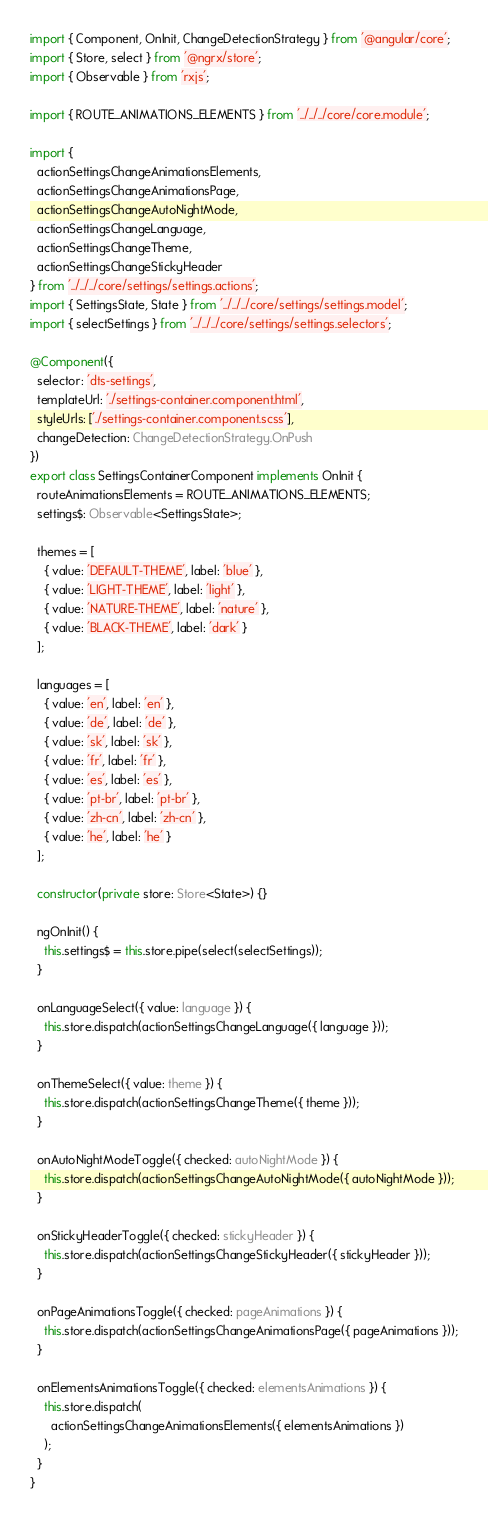Convert code to text. <code><loc_0><loc_0><loc_500><loc_500><_TypeScript_>import { Component, OnInit, ChangeDetectionStrategy } from '@angular/core';
import { Store, select } from '@ngrx/store';
import { Observable } from 'rxjs';

import { ROUTE_ANIMATIONS_ELEMENTS } from '../../../core/core.module';

import {
  actionSettingsChangeAnimationsElements,
  actionSettingsChangeAnimationsPage,
  actionSettingsChangeAutoNightMode,
  actionSettingsChangeLanguage,
  actionSettingsChangeTheme,
  actionSettingsChangeStickyHeader
} from '../../../core/settings/settings.actions';
import { SettingsState, State } from '../../../core/settings/settings.model';
import { selectSettings } from '../../../core/settings/settings.selectors';

@Component({
  selector: 'dts-settings',
  templateUrl: './settings-container.component.html',
  styleUrls: ['./settings-container.component.scss'],
  changeDetection: ChangeDetectionStrategy.OnPush
})
export class SettingsContainerComponent implements OnInit {
  routeAnimationsElements = ROUTE_ANIMATIONS_ELEMENTS;
  settings$: Observable<SettingsState>;

  themes = [
    { value: 'DEFAULT-THEME', label: 'blue' },
    { value: 'LIGHT-THEME', label: 'light' },
    { value: 'NATURE-THEME', label: 'nature' },
    { value: 'BLACK-THEME', label: 'dark' }
  ];

  languages = [
    { value: 'en', label: 'en' },
    { value: 'de', label: 'de' },
    { value: 'sk', label: 'sk' },
    { value: 'fr', label: 'fr' },
    { value: 'es', label: 'es' },
    { value: 'pt-br', label: 'pt-br' },
    { value: 'zh-cn', label: 'zh-cn' },
    { value: 'he', label: 'he' }
  ];

  constructor(private store: Store<State>) {}

  ngOnInit() {
    this.settings$ = this.store.pipe(select(selectSettings));
  }

  onLanguageSelect({ value: language }) {
    this.store.dispatch(actionSettingsChangeLanguage({ language }));
  }

  onThemeSelect({ value: theme }) {
    this.store.dispatch(actionSettingsChangeTheme({ theme }));
  }

  onAutoNightModeToggle({ checked: autoNightMode }) {
    this.store.dispatch(actionSettingsChangeAutoNightMode({ autoNightMode }));
  }

  onStickyHeaderToggle({ checked: stickyHeader }) {
    this.store.dispatch(actionSettingsChangeStickyHeader({ stickyHeader }));
  }

  onPageAnimationsToggle({ checked: pageAnimations }) {
    this.store.dispatch(actionSettingsChangeAnimationsPage({ pageAnimations }));
  }

  onElementsAnimationsToggle({ checked: elementsAnimations }) {
    this.store.dispatch(
      actionSettingsChangeAnimationsElements({ elementsAnimations })
    );
  }
}
</code> 